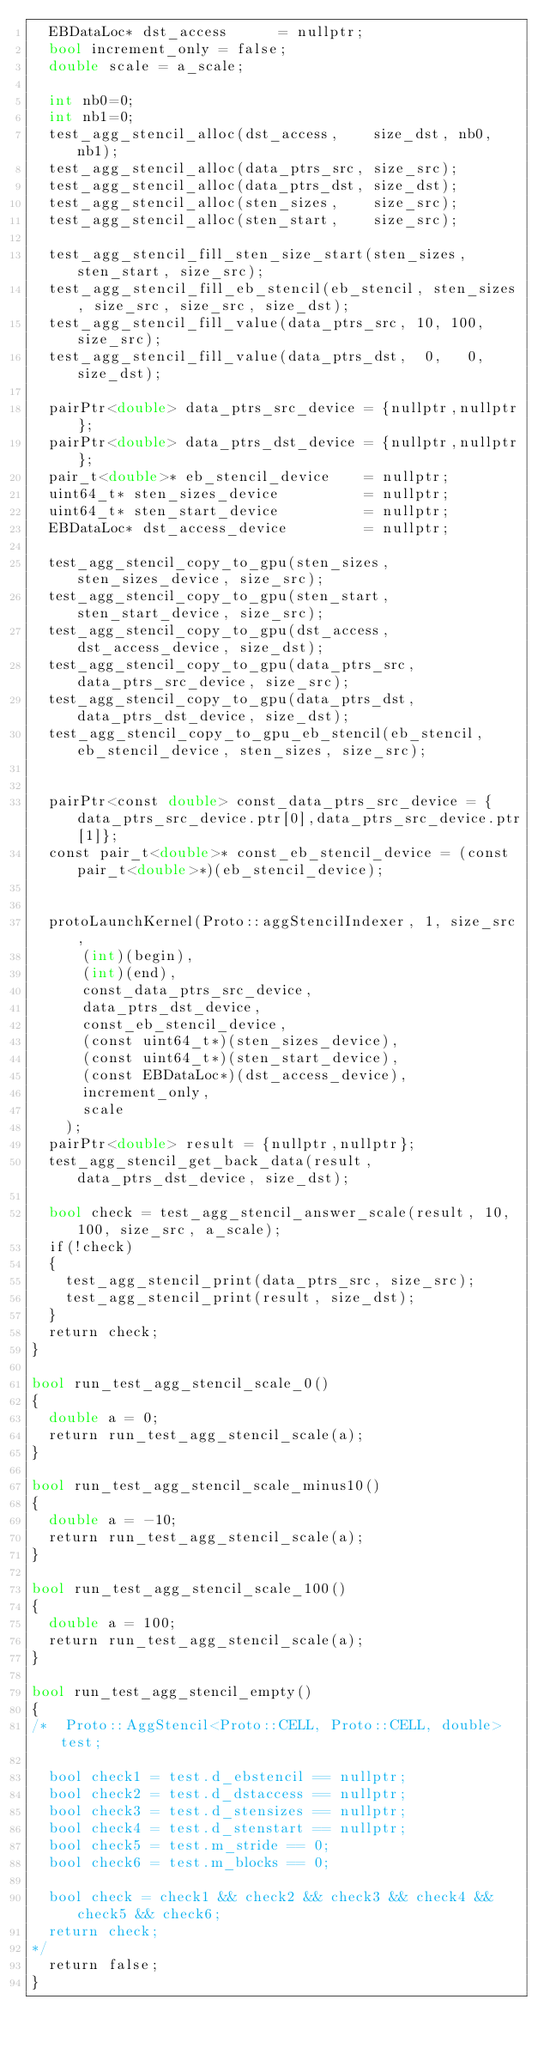Convert code to text. <code><loc_0><loc_0><loc_500><loc_500><_Cuda_>  EBDataLoc* dst_access      = nullptr;
  bool increment_only = false;
  double scale = a_scale;

  int nb0=0;
  int nb1=0;
  test_agg_stencil_alloc(dst_access,    size_dst, nb0, nb1);
  test_agg_stencil_alloc(data_ptrs_src, size_src); 
  test_agg_stencil_alloc(data_ptrs_dst, size_dst); 
  test_agg_stencil_alloc(sten_sizes,    size_src);  
  test_agg_stencil_alloc(sten_start,    size_src);    

  test_agg_stencil_fill_sten_size_start(sten_sizes, sten_start, size_src);
  test_agg_stencil_fill_eb_stencil(eb_stencil, sten_sizes, size_src, size_src, size_dst);
  test_agg_stencil_fill_value(data_ptrs_src, 10, 100, size_src);
  test_agg_stencil_fill_value(data_ptrs_dst,  0,   0, size_dst);

  pairPtr<double> data_ptrs_src_device = {nullptr,nullptr};
  pairPtr<double> data_ptrs_dst_device = {nullptr,nullptr};
  pair_t<double>* eb_stencil_device    = nullptr;
  uint64_t* sten_sizes_device          = nullptr;
  uint64_t* sten_start_device          = nullptr;
  EBDataLoc* dst_access_device         = nullptr;

  test_agg_stencil_copy_to_gpu(sten_sizes, sten_sizes_device, size_src);
  test_agg_stencil_copy_to_gpu(sten_start, sten_start_device, size_src);
  test_agg_stencil_copy_to_gpu(dst_access, dst_access_device, size_dst);
  test_agg_stencil_copy_to_gpu(data_ptrs_src, data_ptrs_src_device, size_src);
  test_agg_stencil_copy_to_gpu(data_ptrs_dst, data_ptrs_dst_device, size_dst);
  test_agg_stencil_copy_to_gpu_eb_stencil(eb_stencil, eb_stencil_device, sten_sizes, size_src);


  pairPtr<const double> const_data_ptrs_src_device = {data_ptrs_src_device.ptr[0],data_ptrs_src_device.ptr[1]};
  const pair_t<double>* const_eb_stencil_device = (const pair_t<double>*)(eb_stencil_device);


  protoLaunchKernel(Proto::aggStencilIndexer, 1, size_src,
			(int)(begin), 
			(int)(end),
			const_data_ptrs_src_device,
			data_ptrs_dst_device,
			const_eb_stencil_device,
			(const uint64_t*)(sten_sizes_device),
			(const uint64_t*)(sten_start_device),
			(const EBDataLoc*)(dst_access_device),
			increment_only,
			scale		
		);
  pairPtr<double> result = {nullptr,nullptr};
  test_agg_stencil_get_back_data(result, data_ptrs_dst_device, size_dst);

  bool check = test_agg_stencil_answer_scale(result, 10, 100, size_src, a_scale);
  if(!check) 
  {
    test_agg_stencil_print(data_ptrs_src, size_src);
    test_agg_stencil_print(result, size_dst);
  }
  return check;
}

bool run_test_agg_stencil_scale_0()
{
  double a = 0;
  return run_test_agg_stencil_scale(a);
}

bool run_test_agg_stencil_scale_minus10()
{
  double a = -10;
  return run_test_agg_stencil_scale(a);
}

bool run_test_agg_stencil_scale_100()
{
  double a = 100;
  return run_test_agg_stencil_scale(a);
}

bool run_test_agg_stencil_empty()
{
/*  Proto::AggStencil<Proto::CELL, Proto::CELL, double> test;

  bool check1 = test.d_ebstencil == nullptr; 
  bool check2 = test.d_dstaccess == nullptr; 
  bool check3 = test.d_stensizes == nullptr; 
  bool check4 = test.d_stenstart == nullptr; 
  bool check5 = test.m_stride == 0; 
  bool check6 = test.m_blocks == 0; 

  bool check = check1 && check2 && check3 && check4 && check5 && check6;
  return check;
*/
  return false;
}
</code> 